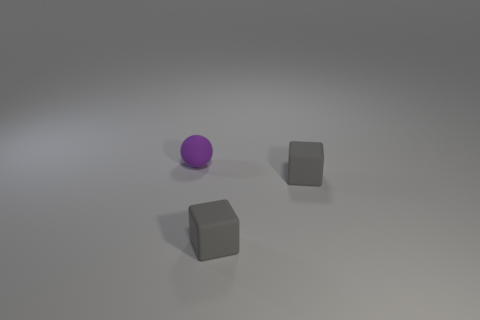What is the small purple sphere made of?
Your answer should be compact. Rubber. Is there another purple sphere of the same size as the purple rubber sphere?
Your answer should be very brief. No. Is the number of gray cubes greater than the number of large purple rubber cylinders?
Keep it short and to the point. Yes. What number of metallic things are either purple spheres or tiny gray cubes?
Your answer should be very brief. 0. How many rubber objects have the same color as the matte ball?
Provide a succinct answer. 0. How many large things are either spheres or red balls?
Keep it short and to the point. 0. How many purple balls are the same material as the purple thing?
Your response must be concise. 0. Are there fewer matte things that are in front of the rubber sphere than gray matte cubes?
Your answer should be compact. No. Are there any other things that are the same shape as the tiny purple object?
Make the answer very short. No. How many things are matte things or tiny green shiny blocks?
Your response must be concise. 3. 